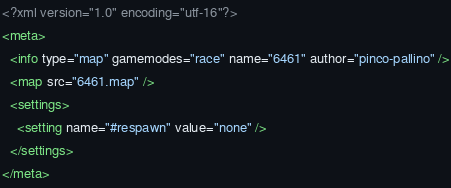<code> <loc_0><loc_0><loc_500><loc_500><_XML_><?xml version="1.0" encoding="utf-16"?>
<meta>
  <info type="map" gamemodes="race" name="6461" author="pinco-pallino" />
  <map src="6461.map" />
  <settings>
    <setting name="#respawn" value="none" />
  </settings>
</meta></code> 